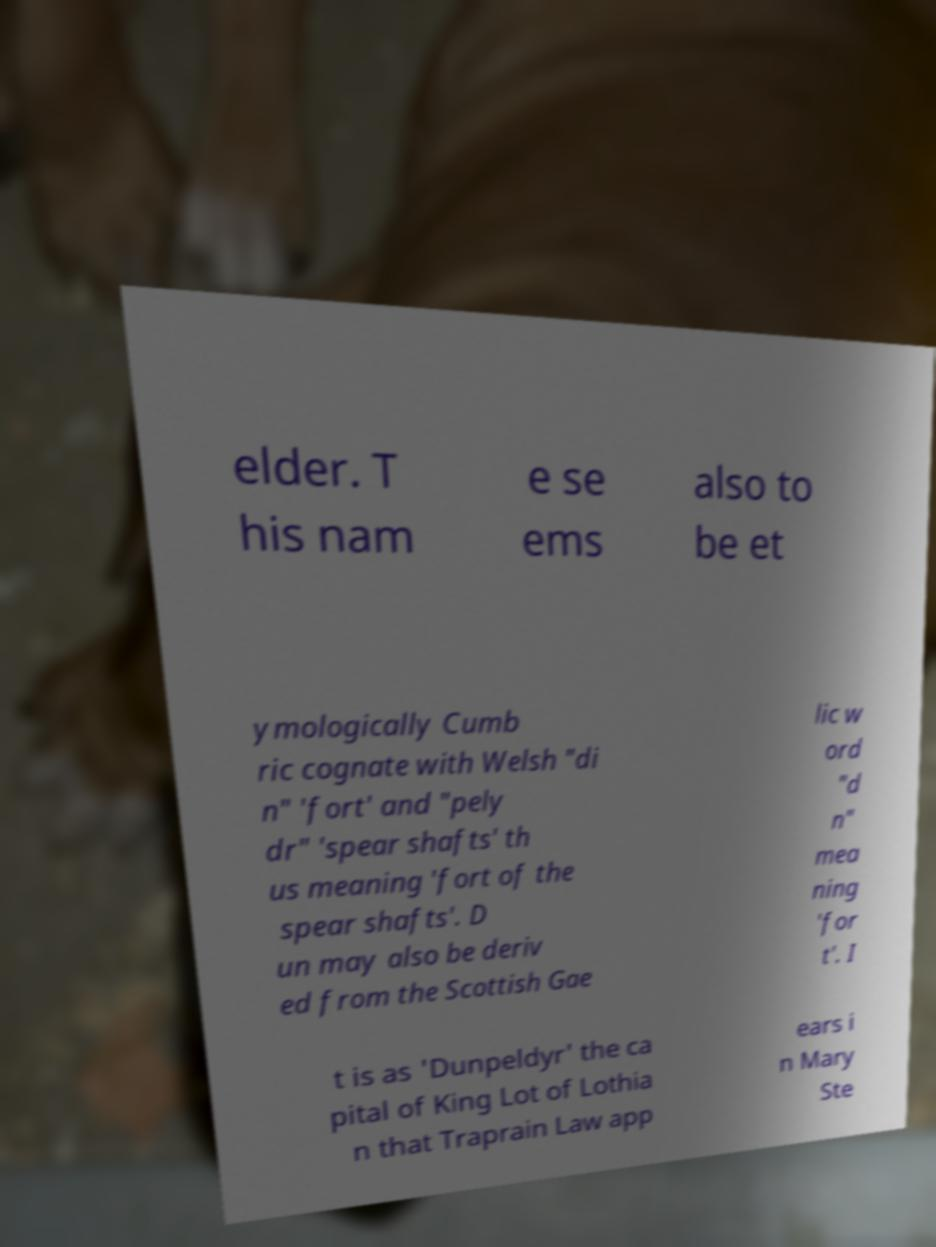Could you extract and type out the text from this image? elder. T his nam e se ems also to be et ymologically Cumb ric cognate with Welsh "di n" 'fort' and "pely dr" 'spear shafts' th us meaning 'fort of the spear shafts'. D un may also be deriv ed from the Scottish Gae lic w ord "d n" mea ning 'for t'. I t is as 'Dunpeldyr' the ca pital of King Lot of Lothia n that Traprain Law app ears i n Mary Ste 